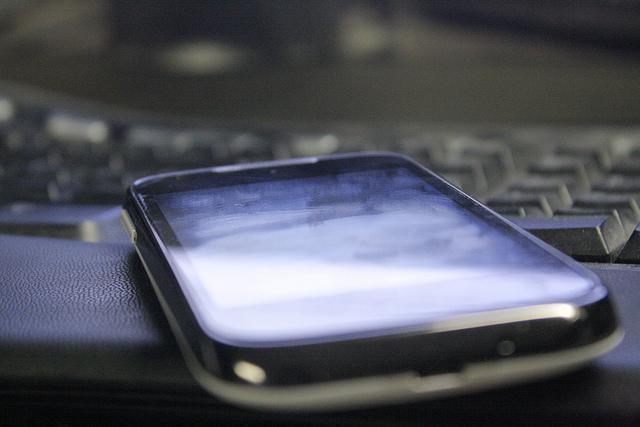How many vases glass vases are on the table?
Give a very brief answer. 0. 